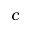Convert formula to latex. <formula><loc_0><loc_0><loc_500><loc_500>c</formula> 